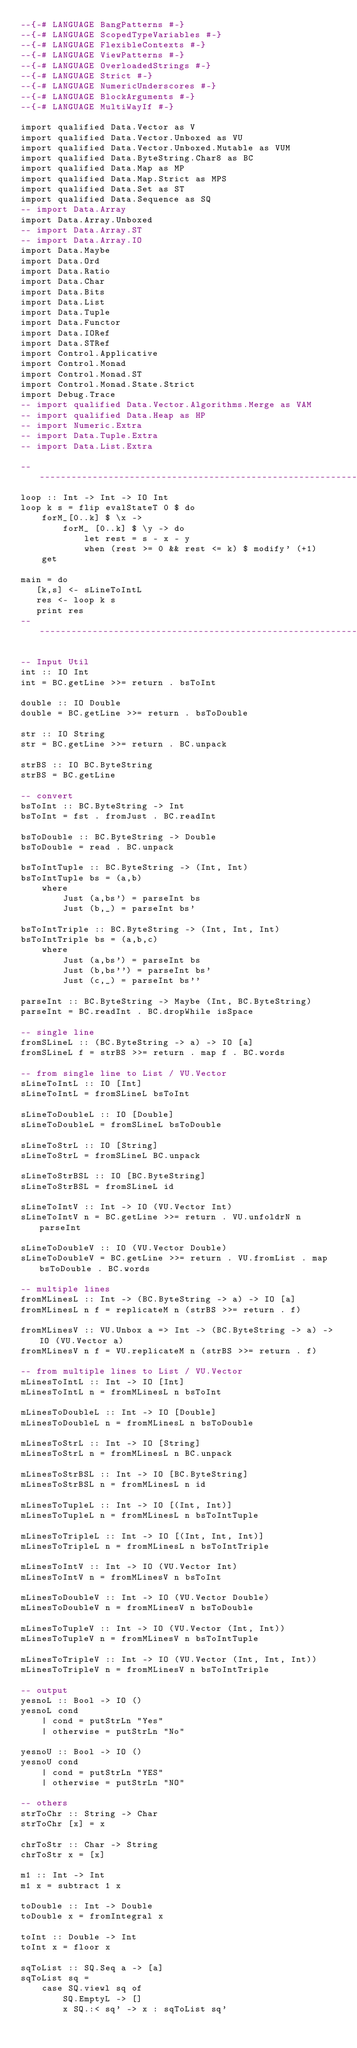<code> <loc_0><loc_0><loc_500><loc_500><_Haskell_>--{-# LANGUAGE BangPatterns #-}
--{-# LANGUAGE ScopedTypeVariables #-}
--{-# LANGUAGE FlexibleContexts #-}
--{-# LANGUAGE ViewPatterns #-}
--{-# LANGUAGE OverloadedStrings #-}
--{-# LANGUAGE Strict #-}
--{-# LANGUAGE NumericUnderscores #-}
--{-# LANGUAGE BlockArguments #-}
--{-# LANGUAGE MultiWayIf #-}

import qualified Data.Vector as V
import qualified Data.Vector.Unboxed as VU
import qualified Data.Vector.Unboxed.Mutable as VUM
import qualified Data.ByteString.Char8 as BC
import qualified Data.Map as MP
import qualified Data.Map.Strict as MPS
import qualified Data.Set as ST
import qualified Data.Sequence as SQ
-- import Data.Array
import Data.Array.Unboxed
-- import Data.Array.ST
-- import Data.Array.IO
import Data.Maybe
import Data.Ord
import Data.Ratio
import Data.Char
import Data.Bits
import Data.List
import Data.Tuple
import Data.Functor
import Data.IORef
import Data.STRef
import Control.Applicative
import Control.Monad
import Control.Monad.ST
import Control.Monad.State.Strict
import Debug.Trace
-- import qualified Data.Vector.Algorithms.Merge as VAM
-- import qualified Data.Heap as HP
-- import Numeric.Extra
-- import Data.Tuple.Extra
-- import Data.List.Extra

--------------------------------------------------------------------------
loop :: Int -> Int -> IO Int
loop k s = flip evalStateT 0 $ do
    forM_[0..k] $ \x ->
        forM_ [0..k] $ \y -> do
            let rest = s - x - y
            when (rest >= 0 && rest <= k) $ modify' (+1)
    get

main = do
   [k,s] <- sLineToIntL
   res <- loop k s
   print res
--------------------------------------------------------------------------

-- Input Util
int :: IO Int
int = BC.getLine >>= return . bsToInt

double :: IO Double
double = BC.getLine >>= return . bsToDouble

str :: IO String
str = BC.getLine >>= return . BC.unpack

strBS :: IO BC.ByteString
strBS = BC.getLine

-- convert
bsToInt :: BC.ByteString -> Int
bsToInt = fst . fromJust . BC.readInt

bsToDouble :: BC.ByteString -> Double
bsToDouble = read . BC.unpack

bsToIntTuple :: BC.ByteString -> (Int, Int)
bsToIntTuple bs = (a,b)
    where
        Just (a,bs') = parseInt bs
        Just (b,_) = parseInt bs'

bsToIntTriple :: BC.ByteString -> (Int, Int, Int)
bsToIntTriple bs = (a,b,c)
    where
        Just (a,bs') = parseInt bs
        Just (b,bs'') = parseInt bs'
        Just (c,_) = parseInt bs''

parseInt :: BC.ByteString -> Maybe (Int, BC.ByteString)
parseInt = BC.readInt . BC.dropWhile isSpace

-- single line
fromSLineL :: (BC.ByteString -> a) -> IO [a]
fromSLineL f = strBS >>= return . map f . BC.words

-- from single line to List / VU.Vector 
sLineToIntL :: IO [Int]
sLineToIntL = fromSLineL bsToInt

sLineToDoubleL :: IO [Double]
sLineToDoubleL = fromSLineL bsToDouble

sLineToStrL :: IO [String]
sLineToStrL = fromSLineL BC.unpack

sLineToStrBSL :: IO [BC.ByteString]
sLineToStrBSL = fromSLineL id 

sLineToIntV :: Int -> IO (VU.Vector Int)
sLineToIntV n = BC.getLine >>= return . VU.unfoldrN n parseInt

sLineToDoubleV :: IO (VU.Vector Double)
sLineToDoubleV = BC.getLine >>= return . VU.fromList . map bsToDouble . BC.words

-- multiple lines
fromMLinesL :: Int -> (BC.ByteString -> a) -> IO [a]
fromMLinesL n f = replicateM n (strBS >>= return . f)

fromMLinesV :: VU.Unbox a => Int -> (BC.ByteString -> a) -> IO (VU.Vector a)
fromMLinesV n f = VU.replicateM n (strBS >>= return . f)

-- from multiple lines to List / VU.Vector
mLinesToIntL :: Int -> IO [Int]
mLinesToIntL n = fromMLinesL n bsToInt

mLinesToDoubleL :: Int -> IO [Double]
mLinesToDoubleL n = fromMLinesL n bsToDouble

mLinesToStrL :: Int -> IO [String]
mLinesToStrL n = fromMLinesL n BC.unpack

mLinesToStrBSL :: Int -> IO [BC.ByteString]
mLinesToStrBSL n = fromMLinesL n id

mLinesToTupleL :: Int -> IO [(Int, Int)]
mLinesToTupleL n = fromMLinesL n bsToIntTuple

mLinesToTripleL :: Int -> IO [(Int, Int, Int)]
mLinesToTripleL n = fromMLinesL n bsToIntTriple

mLinesToIntV :: Int -> IO (VU.Vector Int)
mLinesToIntV n = fromMLinesV n bsToInt

mLinesToDoubleV :: Int -> IO (VU.Vector Double)
mLinesToDoubleV n = fromMLinesV n bsToDouble

mLinesToTupleV :: Int -> IO (VU.Vector (Int, Int))
mLinesToTupleV n = fromMLinesV n bsToIntTuple
    
mLinesToTripleV :: Int -> IO (VU.Vector (Int, Int, Int))
mLinesToTripleV n = fromMLinesV n bsToIntTriple

-- output
yesnoL :: Bool -> IO ()
yesnoL cond
    | cond = putStrLn "Yes"
    | otherwise = putStrLn "No"

yesnoU :: Bool -> IO ()
yesnoU cond
    | cond = putStrLn "YES"
    | otherwise = putStrLn "NO"

-- others
strToChr :: String -> Char
strToChr [x] = x

chrToStr :: Char -> String
chrToStr x = [x]

m1 :: Int -> Int
m1 x = subtract 1 x

toDouble :: Int -> Double
toDouble x = fromIntegral x

toInt :: Double -> Int
toInt x = floor x

sqToList :: SQ.Seq a -> [a]
sqToList sq = 
    case SQ.viewl sq of
        SQ.EmptyL -> []
        x SQ.:< sq' -> x : sqToList sq'
</code> 